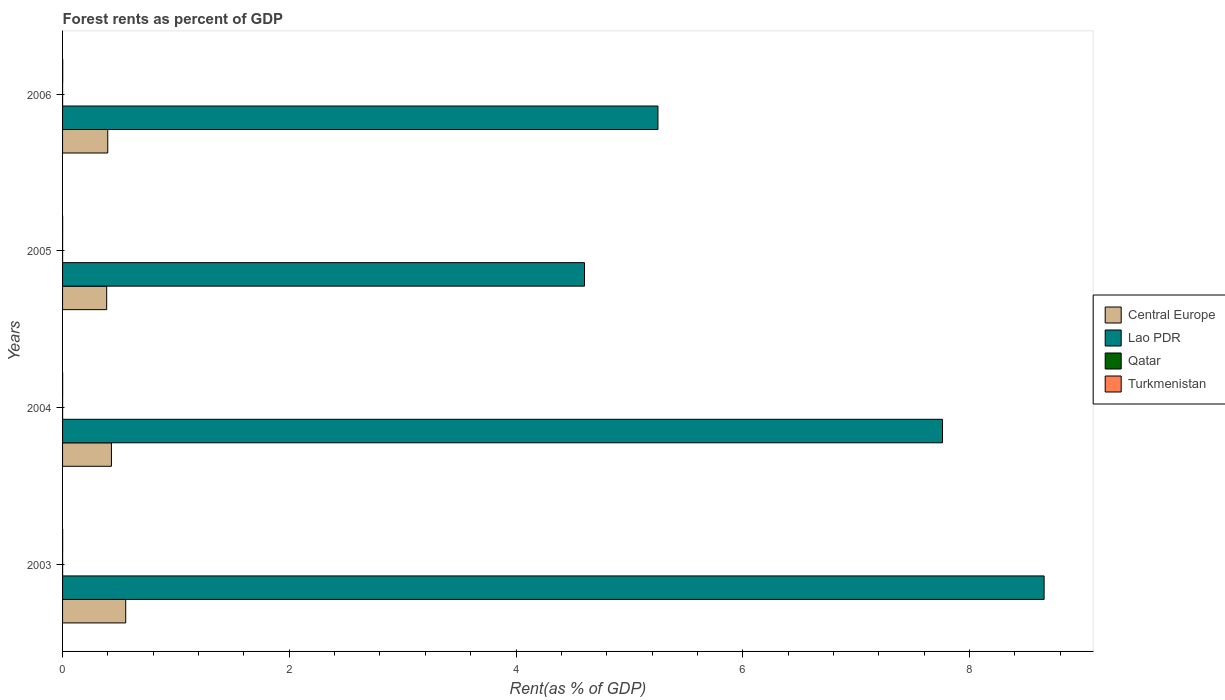How many groups of bars are there?
Your answer should be compact. 4. Are the number of bars per tick equal to the number of legend labels?
Provide a succinct answer. Yes. Are the number of bars on each tick of the Y-axis equal?
Offer a terse response. Yes. How many bars are there on the 3rd tick from the bottom?
Offer a terse response. 4. What is the label of the 4th group of bars from the top?
Make the answer very short. 2003. What is the forest rent in Lao PDR in 2006?
Your answer should be very brief. 5.25. Across all years, what is the maximum forest rent in Turkmenistan?
Your answer should be very brief. 0. Across all years, what is the minimum forest rent in Lao PDR?
Make the answer very short. 4.6. In which year was the forest rent in Central Europe maximum?
Your response must be concise. 2003. In which year was the forest rent in Qatar minimum?
Give a very brief answer. 2006. What is the total forest rent in Qatar in the graph?
Offer a terse response. 0. What is the difference between the forest rent in Lao PDR in 2005 and that in 2006?
Offer a very short reply. -0.65. What is the difference between the forest rent in Lao PDR in 2006 and the forest rent in Central Europe in 2003?
Ensure brevity in your answer.  4.7. What is the average forest rent in Turkmenistan per year?
Your answer should be compact. 0. In the year 2005, what is the difference between the forest rent in Central Europe and forest rent in Lao PDR?
Keep it short and to the point. -4.22. In how many years, is the forest rent in Lao PDR greater than 4 %?
Provide a succinct answer. 4. What is the ratio of the forest rent in Lao PDR in 2003 to that in 2006?
Your response must be concise. 1.65. Is the forest rent in Lao PDR in 2003 less than that in 2006?
Offer a very short reply. No. What is the difference between the highest and the second highest forest rent in Lao PDR?
Ensure brevity in your answer.  0.9. What is the difference between the highest and the lowest forest rent in Qatar?
Provide a short and direct response. 0. In how many years, is the forest rent in Qatar greater than the average forest rent in Qatar taken over all years?
Ensure brevity in your answer.  2. Is the sum of the forest rent in Central Europe in 2005 and 2006 greater than the maximum forest rent in Qatar across all years?
Ensure brevity in your answer.  Yes. What does the 1st bar from the top in 2006 represents?
Offer a very short reply. Turkmenistan. What does the 3rd bar from the bottom in 2005 represents?
Ensure brevity in your answer.  Qatar. Is it the case that in every year, the sum of the forest rent in Turkmenistan and forest rent in Lao PDR is greater than the forest rent in Central Europe?
Offer a terse response. Yes. How many bars are there?
Make the answer very short. 16. Are the values on the major ticks of X-axis written in scientific E-notation?
Your answer should be very brief. No. Does the graph contain grids?
Provide a short and direct response. No. Where does the legend appear in the graph?
Offer a very short reply. Center right. How many legend labels are there?
Your response must be concise. 4. How are the legend labels stacked?
Offer a terse response. Vertical. What is the title of the graph?
Offer a very short reply. Forest rents as percent of GDP. Does "Libya" appear as one of the legend labels in the graph?
Your answer should be very brief. No. What is the label or title of the X-axis?
Keep it short and to the point. Rent(as % of GDP). What is the Rent(as % of GDP) in Central Europe in 2003?
Offer a terse response. 0.56. What is the Rent(as % of GDP) in Lao PDR in 2003?
Provide a short and direct response. 8.66. What is the Rent(as % of GDP) in Qatar in 2003?
Offer a very short reply. 0. What is the Rent(as % of GDP) of Turkmenistan in 2003?
Provide a succinct answer. 0. What is the Rent(as % of GDP) of Central Europe in 2004?
Make the answer very short. 0.43. What is the Rent(as % of GDP) in Lao PDR in 2004?
Ensure brevity in your answer.  7.76. What is the Rent(as % of GDP) of Qatar in 2004?
Provide a short and direct response. 0. What is the Rent(as % of GDP) in Turkmenistan in 2004?
Your answer should be very brief. 0. What is the Rent(as % of GDP) of Central Europe in 2005?
Give a very brief answer. 0.39. What is the Rent(as % of GDP) of Lao PDR in 2005?
Provide a short and direct response. 4.6. What is the Rent(as % of GDP) of Qatar in 2005?
Give a very brief answer. 0. What is the Rent(as % of GDP) in Turkmenistan in 2005?
Ensure brevity in your answer.  0. What is the Rent(as % of GDP) in Central Europe in 2006?
Keep it short and to the point. 0.4. What is the Rent(as % of GDP) of Lao PDR in 2006?
Your answer should be very brief. 5.25. What is the Rent(as % of GDP) in Qatar in 2006?
Your answer should be very brief. 0. What is the Rent(as % of GDP) in Turkmenistan in 2006?
Give a very brief answer. 0. Across all years, what is the maximum Rent(as % of GDP) in Central Europe?
Your response must be concise. 0.56. Across all years, what is the maximum Rent(as % of GDP) of Lao PDR?
Make the answer very short. 8.66. Across all years, what is the maximum Rent(as % of GDP) of Qatar?
Your answer should be compact. 0. Across all years, what is the maximum Rent(as % of GDP) in Turkmenistan?
Ensure brevity in your answer.  0. Across all years, what is the minimum Rent(as % of GDP) in Central Europe?
Give a very brief answer. 0.39. Across all years, what is the minimum Rent(as % of GDP) in Lao PDR?
Offer a terse response. 4.6. Across all years, what is the minimum Rent(as % of GDP) in Qatar?
Ensure brevity in your answer.  0. Across all years, what is the minimum Rent(as % of GDP) of Turkmenistan?
Your response must be concise. 0. What is the total Rent(as % of GDP) in Central Europe in the graph?
Offer a terse response. 1.78. What is the total Rent(as % of GDP) in Lao PDR in the graph?
Provide a short and direct response. 26.28. What is the total Rent(as % of GDP) in Qatar in the graph?
Your answer should be compact. 0. What is the total Rent(as % of GDP) of Turkmenistan in the graph?
Give a very brief answer. 0. What is the difference between the Rent(as % of GDP) in Central Europe in 2003 and that in 2004?
Your response must be concise. 0.13. What is the difference between the Rent(as % of GDP) in Lao PDR in 2003 and that in 2004?
Keep it short and to the point. 0.9. What is the difference between the Rent(as % of GDP) of Turkmenistan in 2003 and that in 2004?
Ensure brevity in your answer.  0. What is the difference between the Rent(as % of GDP) in Central Europe in 2003 and that in 2005?
Offer a very short reply. 0.17. What is the difference between the Rent(as % of GDP) of Lao PDR in 2003 and that in 2005?
Give a very brief answer. 4.05. What is the difference between the Rent(as % of GDP) in Qatar in 2003 and that in 2005?
Your response must be concise. 0. What is the difference between the Rent(as % of GDP) of Central Europe in 2003 and that in 2006?
Ensure brevity in your answer.  0.16. What is the difference between the Rent(as % of GDP) of Lao PDR in 2003 and that in 2006?
Your answer should be compact. 3.41. What is the difference between the Rent(as % of GDP) in Turkmenistan in 2003 and that in 2006?
Keep it short and to the point. -0. What is the difference between the Rent(as % of GDP) of Central Europe in 2004 and that in 2005?
Give a very brief answer. 0.04. What is the difference between the Rent(as % of GDP) in Lao PDR in 2004 and that in 2005?
Offer a very short reply. 3.16. What is the difference between the Rent(as % of GDP) in Central Europe in 2004 and that in 2006?
Your answer should be compact. 0.03. What is the difference between the Rent(as % of GDP) in Lao PDR in 2004 and that in 2006?
Keep it short and to the point. 2.51. What is the difference between the Rent(as % of GDP) of Turkmenistan in 2004 and that in 2006?
Offer a very short reply. -0. What is the difference between the Rent(as % of GDP) in Central Europe in 2005 and that in 2006?
Make the answer very short. -0.01. What is the difference between the Rent(as % of GDP) in Lao PDR in 2005 and that in 2006?
Offer a very short reply. -0.65. What is the difference between the Rent(as % of GDP) of Turkmenistan in 2005 and that in 2006?
Ensure brevity in your answer.  -0. What is the difference between the Rent(as % of GDP) in Central Europe in 2003 and the Rent(as % of GDP) in Lao PDR in 2004?
Provide a short and direct response. -7.21. What is the difference between the Rent(as % of GDP) of Central Europe in 2003 and the Rent(as % of GDP) of Qatar in 2004?
Make the answer very short. 0.56. What is the difference between the Rent(as % of GDP) in Central Europe in 2003 and the Rent(as % of GDP) in Turkmenistan in 2004?
Your response must be concise. 0.56. What is the difference between the Rent(as % of GDP) of Lao PDR in 2003 and the Rent(as % of GDP) of Qatar in 2004?
Your response must be concise. 8.66. What is the difference between the Rent(as % of GDP) of Lao PDR in 2003 and the Rent(as % of GDP) of Turkmenistan in 2004?
Provide a short and direct response. 8.66. What is the difference between the Rent(as % of GDP) of Qatar in 2003 and the Rent(as % of GDP) of Turkmenistan in 2004?
Give a very brief answer. -0. What is the difference between the Rent(as % of GDP) of Central Europe in 2003 and the Rent(as % of GDP) of Lao PDR in 2005?
Keep it short and to the point. -4.05. What is the difference between the Rent(as % of GDP) of Central Europe in 2003 and the Rent(as % of GDP) of Qatar in 2005?
Your answer should be very brief. 0.56. What is the difference between the Rent(as % of GDP) of Central Europe in 2003 and the Rent(as % of GDP) of Turkmenistan in 2005?
Your answer should be compact. 0.56. What is the difference between the Rent(as % of GDP) of Lao PDR in 2003 and the Rent(as % of GDP) of Qatar in 2005?
Make the answer very short. 8.66. What is the difference between the Rent(as % of GDP) of Lao PDR in 2003 and the Rent(as % of GDP) of Turkmenistan in 2005?
Your answer should be compact. 8.66. What is the difference between the Rent(as % of GDP) of Qatar in 2003 and the Rent(as % of GDP) of Turkmenistan in 2005?
Your response must be concise. -0. What is the difference between the Rent(as % of GDP) in Central Europe in 2003 and the Rent(as % of GDP) in Lao PDR in 2006?
Your answer should be compact. -4.7. What is the difference between the Rent(as % of GDP) in Central Europe in 2003 and the Rent(as % of GDP) in Qatar in 2006?
Make the answer very short. 0.56. What is the difference between the Rent(as % of GDP) of Central Europe in 2003 and the Rent(as % of GDP) of Turkmenistan in 2006?
Make the answer very short. 0.56. What is the difference between the Rent(as % of GDP) in Lao PDR in 2003 and the Rent(as % of GDP) in Qatar in 2006?
Keep it short and to the point. 8.66. What is the difference between the Rent(as % of GDP) in Lao PDR in 2003 and the Rent(as % of GDP) in Turkmenistan in 2006?
Give a very brief answer. 8.66. What is the difference between the Rent(as % of GDP) in Qatar in 2003 and the Rent(as % of GDP) in Turkmenistan in 2006?
Offer a terse response. -0. What is the difference between the Rent(as % of GDP) of Central Europe in 2004 and the Rent(as % of GDP) of Lao PDR in 2005?
Ensure brevity in your answer.  -4.17. What is the difference between the Rent(as % of GDP) in Central Europe in 2004 and the Rent(as % of GDP) in Qatar in 2005?
Your answer should be compact. 0.43. What is the difference between the Rent(as % of GDP) of Central Europe in 2004 and the Rent(as % of GDP) of Turkmenistan in 2005?
Your answer should be very brief. 0.43. What is the difference between the Rent(as % of GDP) of Lao PDR in 2004 and the Rent(as % of GDP) of Qatar in 2005?
Offer a very short reply. 7.76. What is the difference between the Rent(as % of GDP) of Lao PDR in 2004 and the Rent(as % of GDP) of Turkmenistan in 2005?
Offer a terse response. 7.76. What is the difference between the Rent(as % of GDP) in Qatar in 2004 and the Rent(as % of GDP) in Turkmenistan in 2005?
Ensure brevity in your answer.  -0. What is the difference between the Rent(as % of GDP) of Central Europe in 2004 and the Rent(as % of GDP) of Lao PDR in 2006?
Provide a short and direct response. -4.82. What is the difference between the Rent(as % of GDP) of Central Europe in 2004 and the Rent(as % of GDP) of Qatar in 2006?
Your answer should be very brief. 0.43. What is the difference between the Rent(as % of GDP) of Central Europe in 2004 and the Rent(as % of GDP) of Turkmenistan in 2006?
Your answer should be very brief. 0.43. What is the difference between the Rent(as % of GDP) in Lao PDR in 2004 and the Rent(as % of GDP) in Qatar in 2006?
Your answer should be compact. 7.76. What is the difference between the Rent(as % of GDP) of Lao PDR in 2004 and the Rent(as % of GDP) of Turkmenistan in 2006?
Your answer should be very brief. 7.76. What is the difference between the Rent(as % of GDP) of Qatar in 2004 and the Rent(as % of GDP) of Turkmenistan in 2006?
Your answer should be very brief. -0. What is the difference between the Rent(as % of GDP) of Central Europe in 2005 and the Rent(as % of GDP) of Lao PDR in 2006?
Provide a succinct answer. -4.86. What is the difference between the Rent(as % of GDP) of Central Europe in 2005 and the Rent(as % of GDP) of Qatar in 2006?
Ensure brevity in your answer.  0.39. What is the difference between the Rent(as % of GDP) in Central Europe in 2005 and the Rent(as % of GDP) in Turkmenistan in 2006?
Keep it short and to the point. 0.39. What is the difference between the Rent(as % of GDP) of Lao PDR in 2005 and the Rent(as % of GDP) of Qatar in 2006?
Make the answer very short. 4.6. What is the difference between the Rent(as % of GDP) of Lao PDR in 2005 and the Rent(as % of GDP) of Turkmenistan in 2006?
Keep it short and to the point. 4.6. What is the difference between the Rent(as % of GDP) in Qatar in 2005 and the Rent(as % of GDP) in Turkmenistan in 2006?
Offer a very short reply. -0. What is the average Rent(as % of GDP) of Central Europe per year?
Provide a short and direct response. 0.44. What is the average Rent(as % of GDP) of Lao PDR per year?
Your answer should be very brief. 6.57. What is the average Rent(as % of GDP) in Turkmenistan per year?
Your response must be concise. 0. In the year 2003, what is the difference between the Rent(as % of GDP) of Central Europe and Rent(as % of GDP) of Lao PDR?
Your response must be concise. -8.1. In the year 2003, what is the difference between the Rent(as % of GDP) of Central Europe and Rent(as % of GDP) of Qatar?
Give a very brief answer. 0.56. In the year 2003, what is the difference between the Rent(as % of GDP) in Central Europe and Rent(as % of GDP) in Turkmenistan?
Make the answer very short. 0.56. In the year 2003, what is the difference between the Rent(as % of GDP) in Lao PDR and Rent(as % of GDP) in Qatar?
Your answer should be compact. 8.66. In the year 2003, what is the difference between the Rent(as % of GDP) in Lao PDR and Rent(as % of GDP) in Turkmenistan?
Give a very brief answer. 8.66. In the year 2003, what is the difference between the Rent(as % of GDP) in Qatar and Rent(as % of GDP) in Turkmenistan?
Your answer should be very brief. -0. In the year 2004, what is the difference between the Rent(as % of GDP) of Central Europe and Rent(as % of GDP) of Lao PDR?
Your response must be concise. -7.33. In the year 2004, what is the difference between the Rent(as % of GDP) of Central Europe and Rent(as % of GDP) of Qatar?
Your response must be concise. 0.43. In the year 2004, what is the difference between the Rent(as % of GDP) in Central Europe and Rent(as % of GDP) in Turkmenistan?
Your answer should be compact. 0.43. In the year 2004, what is the difference between the Rent(as % of GDP) of Lao PDR and Rent(as % of GDP) of Qatar?
Your answer should be compact. 7.76. In the year 2004, what is the difference between the Rent(as % of GDP) in Lao PDR and Rent(as % of GDP) in Turkmenistan?
Your answer should be very brief. 7.76. In the year 2004, what is the difference between the Rent(as % of GDP) in Qatar and Rent(as % of GDP) in Turkmenistan?
Your response must be concise. -0. In the year 2005, what is the difference between the Rent(as % of GDP) of Central Europe and Rent(as % of GDP) of Lao PDR?
Keep it short and to the point. -4.22. In the year 2005, what is the difference between the Rent(as % of GDP) of Central Europe and Rent(as % of GDP) of Qatar?
Provide a short and direct response. 0.39. In the year 2005, what is the difference between the Rent(as % of GDP) in Central Europe and Rent(as % of GDP) in Turkmenistan?
Make the answer very short. 0.39. In the year 2005, what is the difference between the Rent(as % of GDP) in Lao PDR and Rent(as % of GDP) in Qatar?
Offer a terse response. 4.6. In the year 2005, what is the difference between the Rent(as % of GDP) of Lao PDR and Rent(as % of GDP) of Turkmenistan?
Your answer should be very brief. 4.6. In the year 2005, what is the difference between the Rent(as % of GDP) of Qatar and Rent(as % of GDP) of Turkmenistan?
Your answer should be compact. -0. In the year 2006, what is the difference between the Rent(as % of GDP) in Central Europe and Rent(as % of GDP) in Lao PDR?
Ensure brevity in your answer.  -4.85. In the year 2006, what is the difference between the Rent(as % of GDP) of Central Europe and Rent(as % of GDP) of Qatar?
Provide a short and direct response. 0.4. In the year 2006, what is the difference between the Rent(as % of GDP) of Central Europe and Rent(as % of GDP) of Turkmenistan?
Give a very brief answer. 0.4. In the year 2006, what is the difference between the Rent(as % of GDP) in Lao PDR and Rent(as % of GDP) in Qatar?
Your answer should be very brief. 5.25. In the year 2006, what is the difference between the Rent(as % of GDP) of Lao PDR and Rent(as % of GDP) of Turkmenistan?
Keep it short and to the point. 5.25. In the year 2006, what is the difference between the Rent(as % of GDP) in Qatar and Rent(as % of GDP) in Turkmenistan?
Offer a terse response. -0. What is the ratio of the Rent(as % of GDP) of Central Europe in 2003 to that in 2004?
Make the answer very short. 1.29. What is the ratio of the Rent(as % of GDP) in Lao PDR in 2003 to that in 2004?
Keep it short and to the point. 1.12. What is the ratio of the Rent(as % of GDP) of Qatar in 2003 to that in 2004?
Your answer should be compact. 1.2. What is the ratio of the Rent(as % of GDP) of Turkmenistan in 2003 to that in 2004?
Offer a very short reply. 1.3. What is the ratio of the Rent(as % of GDP) of Central Europe in 2003 to that in 2005?
Give a very brief answer. 1.43. What is the ratio of the Rent(as % of GDP) of Lao PDR in 2003 to that in 2005?
Ensure brevity in your answer.  1.88. What is the ratio of the Rent(as % of GDP) of Qatar in 2003 to that in 2005?
Offer a very short reply. 1.68. What is the ratio of the Rent(as % of GDP) of Turkmenistan in 2003 to that in 2005?
Keep it short and to the point. 1.46. What is the ratio of the Rent(as % of GDP) in Central Europe in 2003 to that in 2006?
Provide a succinct answer. 1.4. What is the ratio of the Rent(as % of GDP) in Lao PDR in 2003 to that in 2006?
Your answer should be very brief. 1.65. What is the ratio of the Rent(as % of GDP) of Qatar in 2003 to that in 2006?
Make the answer very short. 1.78. What is the ratio of the Rent(as % of GDP) of Turkmenistan in 2003 to that in 2006?
Offer a very short reply. 0.59. What is the ratio of the Rent(as % of GDP) of Central Europe in 2004 to that in 2005?
Ensure brevity in your answer.  1.11. What is the ratio of the Rent(as % of GDP) in Lao PDR in 2004 to that in 2005?
Make the answer very short. 1.69. What is the ratio of the Rent(as % of GDP) of Qatar in 2004 to that in 2005?
Keep it short and to the point. 1.4. What is the ratio of the Rent(as % of GDP) in Turkmenistan in 2004 to that in 2005?
Keep it short and to the point. 1.12. What is the ratio of the Rent(as % of GDP) of Central Europe in 2004 to that in 2006?
Offer a very short reply. 1.08. What is the ratio of the Rent(as % of GDP) of Lao PDR in 2004 to that in 2006?
Keep it short and to the point. 1.48. What is the ratio of the Rent(as % of GDP) of Qatar in 2004 to that in 2006?
Offer a very short reply. 1.48. What is the ratio of the Rent(as % of GDP) in Turkmenistan in 2004 to that in 2006?
Keep it short and to the point. 0.45. What is the ratio of the Rent(as % of GDP) in Central Europe in 2005 to that in 2006?
Give a very brief answer. 0.98. What is the ratio of the Rent(as % of GDP) in Lao PDR in 2005 to that in 2006?
Make the answer very short. 0.88. What is the ratio of the Rent(as % of GDP) in Qatar in 2005 to that in 2006?
Your response must be concise. 1.06. What is the ratio of the Rent(as % of GDP) in Turkmenistan in 2005 to that in 2006?
Your response must be concise. 0.4. What is the difference between the highest and the second highest Rent(as % of GDP) of Central Europe?
Provide a succinct answer. 0.13. What is the difference between the highest and the second highest Rent(as % of GDP) of Lao PDR?
Provide a short and direct response. 0.9. What is the difference between the highest and the second highest Rent(as % of GDP) in Qatar?
Give a very brief answer. 0. What is the difference between the highest and the second highest Rent(as % of GDP) of Turkmenistan?
Provide a short and direct response. 0. What is the difference between the highest and the lowest Rent(as % of GDP) of Central Europe?
Make the answer very short. 0.17. What is the difference between the highest and the lowest Rent(as % of GDP) of Lao PDR?
Your answer should be very brief. 4.05. What is the difference between the highest and the lowest Rent(as % of GDP) of Turkmenistan?
Make the answer very short. 0. 